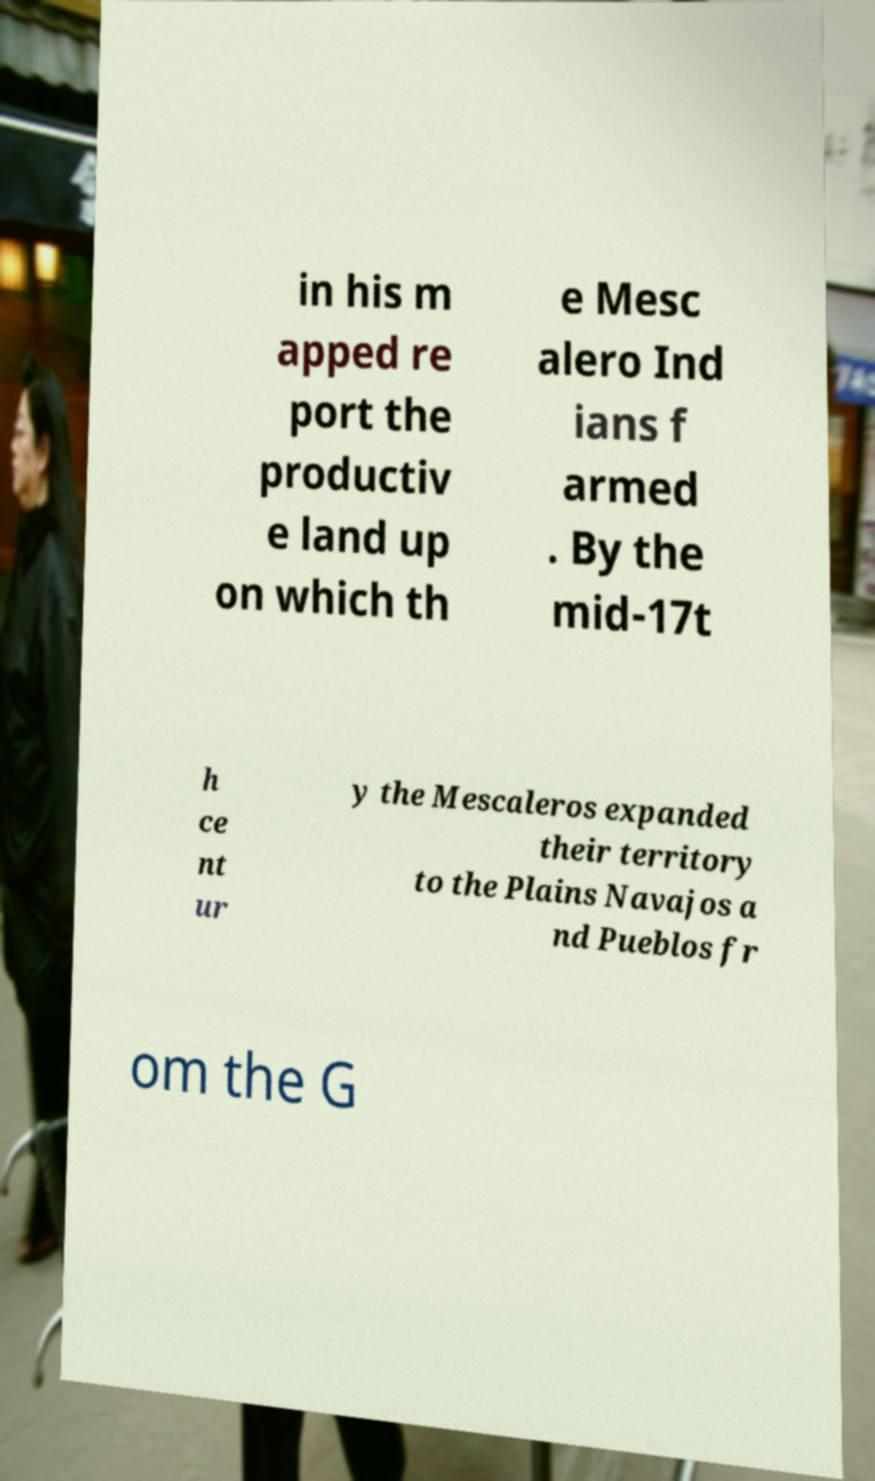Please identify and transcribe the text found in this image. in his m apped re port the productiv e land up on which th e Mesc alero Ind ians f armed . By the mid-17t h ce nt ur y the Mescaleros expanded their territory to the Plains Navajos a nd Pueblos fr om the G 